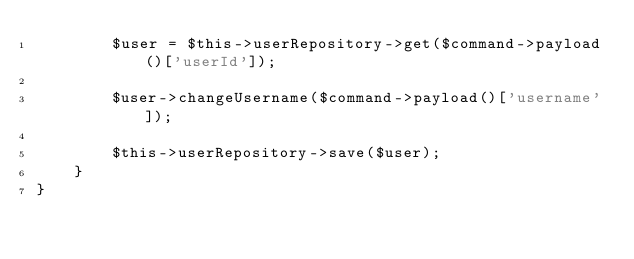Convert code to text. <code><loc_0><loc_0><loc_500><loc_500><_PHP_>        $user = $this->userRepository->get($command->payload()['userId']);

        $user->changeUsername($command->payload()['username']);

        $this->userRepository->save($user);
    }
}
</code> 